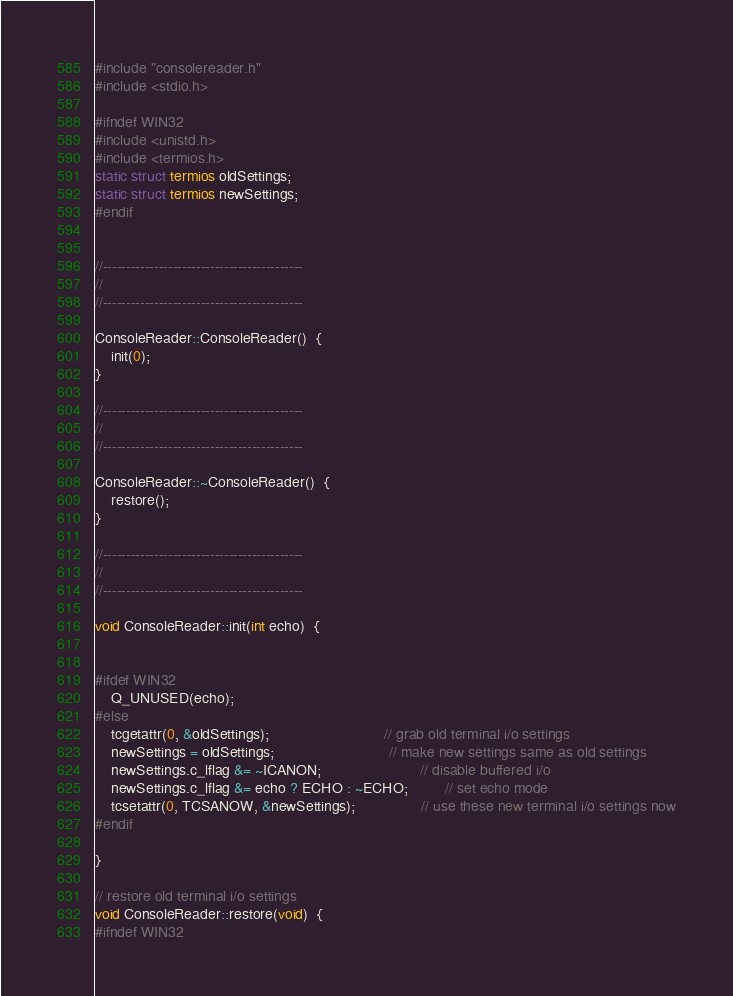Convert code to text. <code><loc_0><loc_0><loc_500><loc_500><_C++_>#include "consolereader.h"
#include <stdio.h>

#ifndef WIN32
#include <unistd.h>
#include <termios.h>
static struct termios oldSettings;
static struct termios newSettings;
#endif


//-------------------------------------------
//
//-------------------------------------------

ConsoleReader::ConsoleReader()  {
	init(0);
}

//-------------------------------------------
//
//-------------------------------------------

ConsoleReader::~ConsoleReader()  {
	restore();
}

//-------------------------------------------
//
//-------------------------------------------

void ConsoleReader::init(int echo)  {


#ifdef WIN32
    Q_UNUSED(echo);
#else
    tcgetattr(0, &oldSettings);							// grab old terminal i/o settings
    newSettings = oldSettings;							// make new settings same as old settings
	newSettings.c_lflag &= ~ICANON;						// disable buffered i/o
    newSettings.c_lflag &= echo ? ECHO : ~ECHO;         // set echo mode
	tcsetattr(0, TCSANOW, &newSettings);				// use these new terminal i/o settings now
#endif

}

// restore old terminal i/o settings
void ConsoleReader::restore(void)  {
#ifndef WIN32</code> 